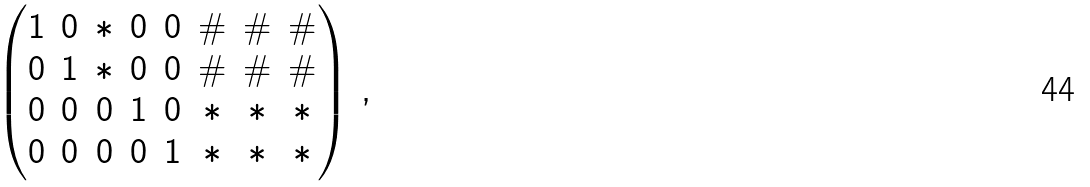<formula> <loc_0><loc_0><loc_500><loc_500>\begin{pmatrix} 1 & 0 & * & 0 & 0 & \# & \# & \# \\ 0 & 1 & * & 0 & 0 & \# & \# & \# \\ 0 & 0 & 0 & 1 & 0 & * & * & * \\ 0 & 0 & 0 & 0 & 1 & * & * & * \\ \end{pmatrix} \, ,</formula> 